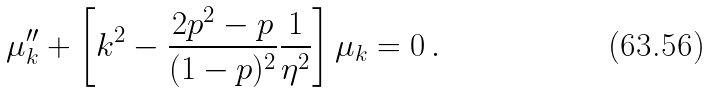<formula> <loc_0><loc_0><loc_500><loc_500>\mu _ { k } ^ { \prime \prime } + \left [ k ^ { 2 } - \frac { 2 p ^ { 2 } - p } { ( 1 - p ) ^ { 2 } } \frac { 1 } { \eta ^ { 2 } } \right ] \mu _ { k } = 0 \, .</formula> 